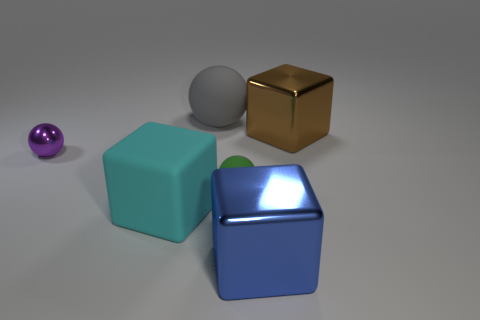What number of objects are either cyan blocks or large gray rubber cylinders?
Keep it short and to the point. 1. There is a green thing that is the same shape as the purple metallic object; what size is it?
Give a very brief answer. Small. What size is the gray ball?
Your answer should be very brief. Large. Is the number of large brown objects that are on the right side of the large matte ball greater than the number of small matte cylinders?
Your answer should be very brief. Yes. There is a block behind the shiny sphere; does it have the same color as the metal thing that is in front of the purple thing?
Ensure brevity in your answer.  No. What is the material of the small sphere on the right side of the big cube that is to the left of the metal cube that is in front of the green rubber sphere?
Ensure brevity in your answer.  Rubber. Are there more brown objects than tiny green blocks?
Provide a succinct answer. Yes. Is there any other thing that has the same color as the big rubber cube?
Your answer should be compact. No. There is a sphere that is made of the same material as the brown block; what size is it?
Keep it short and to the point. Small. What is the big brown cube made of?
Give a very brief answer. Metal. 